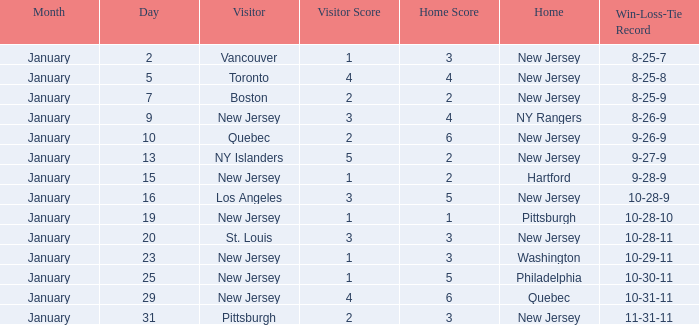What was the date that ended in a record of 8-25-7? January 2. Parse the table in full. {'header': ['Month', 'Day', 'Visitor', 'Visitor Score', 'Home Score', 'Home', 'Win-Loss-Tie Record'], 'rows': [['January', '2', 'Vancouver', '1', '3', 'New Jersey', '8-25-7'], ['January', '5', 'Toronto', '4', '4', 'New Jersey', '8-25-8'], ['January', '7', 'Boston', '2', '2', 'New Jersey', '8-25-9'], ['January', '9', 'New Jersey', '3', '4', 'NY Rangers', '8-26-9'], ['January', '10', 'Quebec', '2', '6', 'New Jersey', '9-26-9'], ['January', '13', 'NY Islanders', '5', '2', 'New Jersey', '9-27-9'], ['January', '15', 'New Jersey', '1', '2', 'Hartford', '9-28-9'], ['January', '16', 'Los Angeles', '3', '5', 'New Jersey', '10-28-9'], ['January', '19', 'New Jersey', '1', '1', 'Pittsburgh', '10-28-10'], ['January', '20', 'St. Louis', '3', '3', 'New Jersey', '10-28-11'], ['January', '23', 'New Jersey', '1', '3', 'Washington', '10-29-11'], ['January', '25', 'New Jersey', '1', '5', 'Philadelphia', '10-30-11'], ['January', '29', 'New Jersey', '4', '6', 'Quebec', '10-31-11'], ['January', '31', 'Pittsburgh', '2', '3', 'New Jersey', '11-31-11']]} 